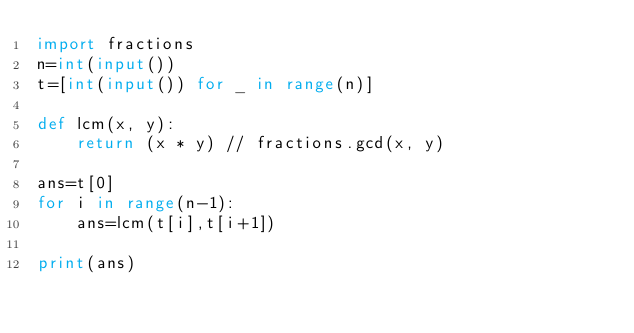<code> <loc_0><loc_0><loc_500><loc_500><_Python_>import fractions
n=int(input())
t=[int(input()) for _ in range(n)]

def lcm(x, y):
    return (x * y) // fractions.gcd(x, y)

ans=t[0]
for i in range(n-1):
    ans=lcm(t[i],t[i+1])

print(ans)
</code> 